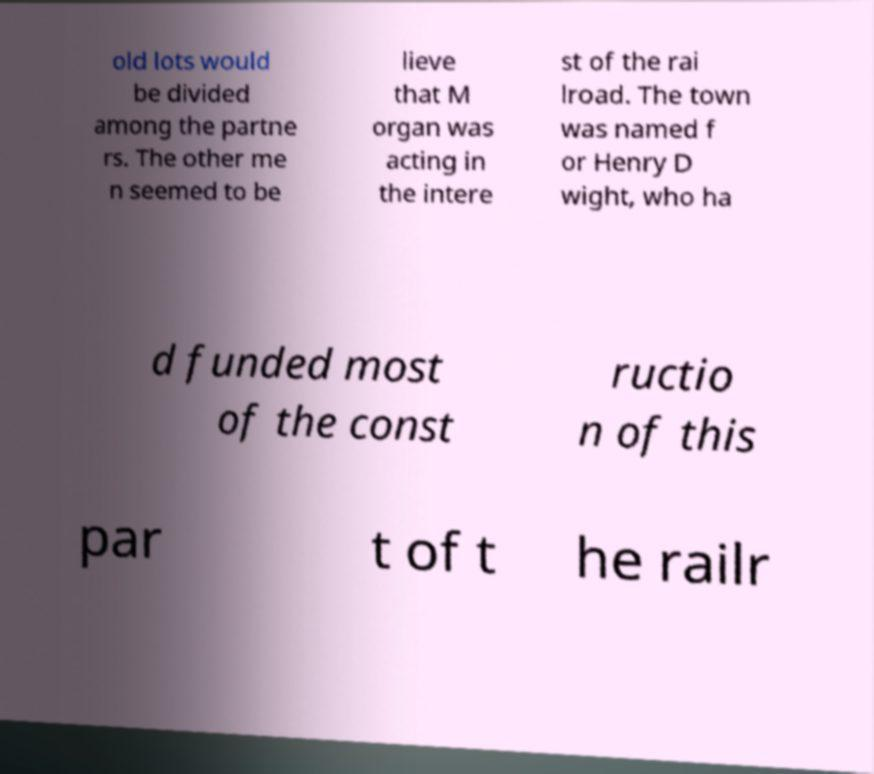Can you read and provide the text displayed in the image?This photo seems to have some interesting text. Can you extract and type it out for me? old lots would be divided among the partne rs. The other me n seemed to be lieve that M organ was acting in the intere st of the rai lroad. The town was named f or Henry D wight, who ha d funded most of the const ructio n of this par t of t he railr 